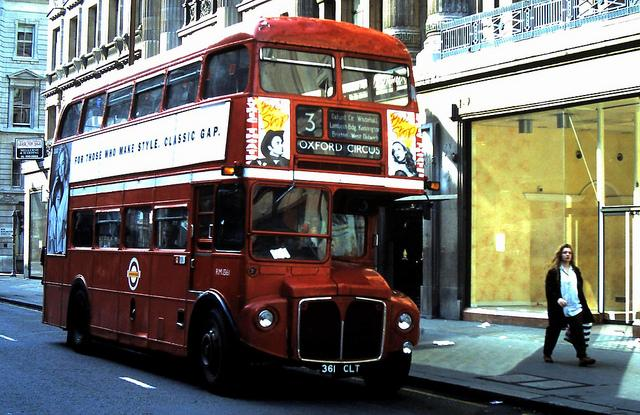What is one of the stops for this bus?

Choices:
A) dublin
B) edinburgh
C) oxford circus
D) victoria station oxford circus 